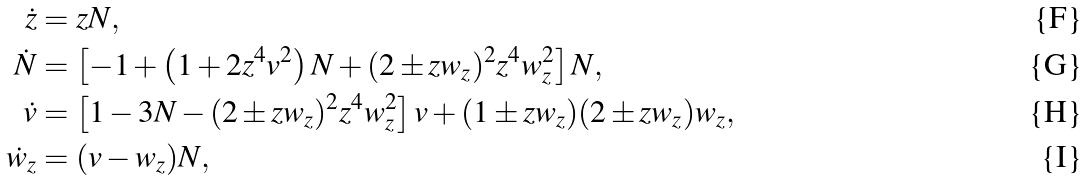Convert formula to latex. <formula><loc_0><loc_0><loc_500><loc_500>\dot { z } & = z N , \\ \dot { N } & = \left [ - 1 + \left ( 1 + 2 z ^ { 4 } v ^ { 2 } \right ) N + ( 2 \pm z w _ { z } ) ^ { 2 } z ^ { 4 } w _ { z } ^ { 2 } \right ] N , \\ \dot { v } & = \left [ 1 - 3 N - ( 2 \pm z w _ { z } ) ^ { 2 } z ^ { 4 } w _ { z } ^ { 2 } \right ] v + ( 1 \pm z w _ { z } ) ( 2 \pm z w _ { z } ) w _ { z } , \\ \dot { w } _ { z } & = ( v - w _ { z } ) N ,</formula> 